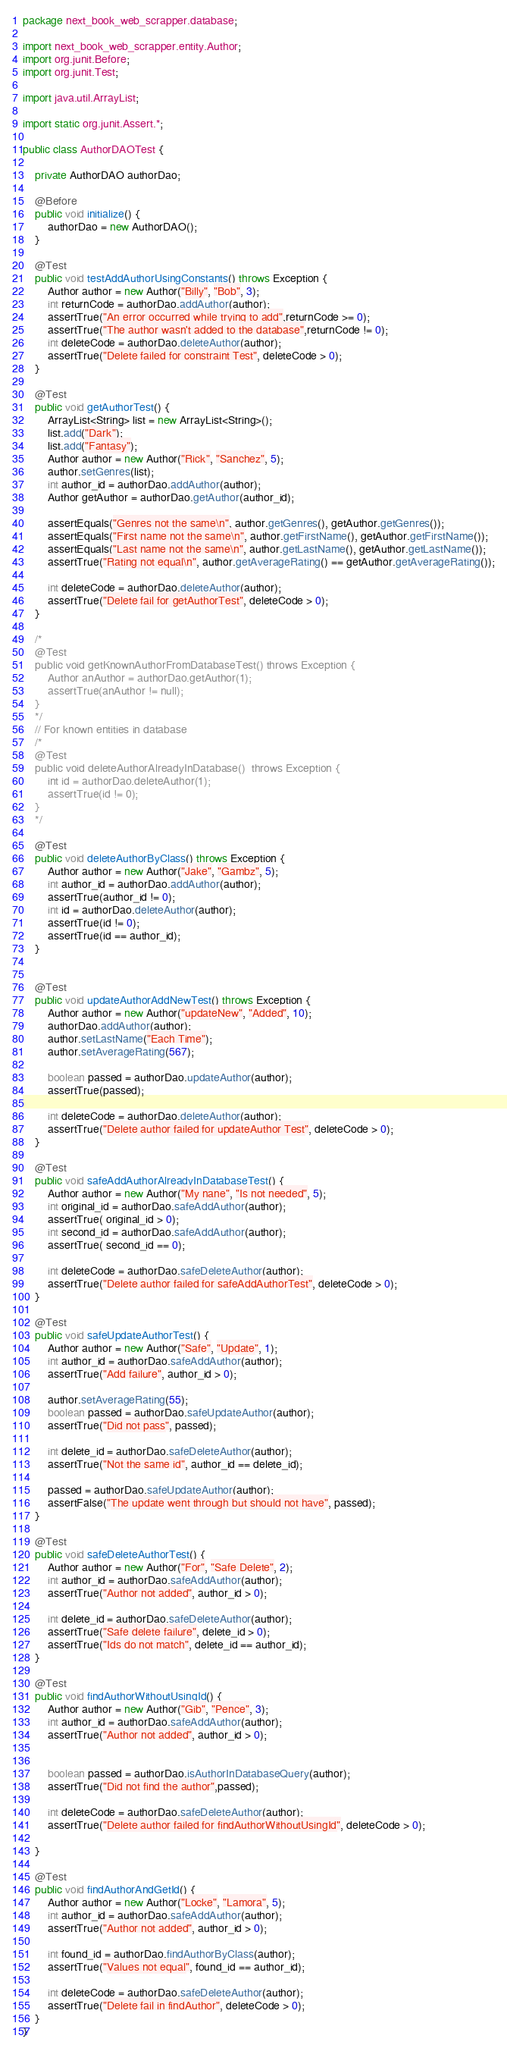<code> <loc_0><loc_0><loc_500><loc_500><_Java_>package next_book_web_scrapper.database;

import next_book_web_scrapper.entity.Author;
import org.junit.Before;
import org.junit.Test;

import java.util.ArrayList;

import static org.junit.Assert.*;

public class AuthorDAOTest {

    private AuthorDAO authorDao;

    @Before
    public void initialize() {
        authorDao = new AuthorDAO();
    }

    @Test
    public void testAddAuthorUsingConstants() throws Exception {
        Author author = new Author("Billy", "Bob", 3);
        int returnCode = authorDao.addAuthor(author);
        assertTrue("An error occurred while trying to add",returnCode >= 0);
        assertTrue("The author wasn't added to the database",returnCode != 0);
        int deleteCode = authorDao.deleteAuthor(author);
        assertTrue("Delete failed for constraint Test", deleteCode > 0);
    }

    @Test
    public void getAuthorTest() {
        ArrayList<String> list = new ArrayList<String>();
        list.add("Dark");
        list.add("Fantasy");
        Author author = new Author("Rick", "Sanchez", 5);
        author.setGenres(list);
        int author_id = authorDao.addAuthor(author);
        Author getAuthor = authorDao.getAuthor(author_id);

        assertEquals("Genres not the same\n", author.getGenres(), getAuthor.getGenres());
        assertEquals("First name not the same\n", author.getFirstName(), getAuthor.getFirstName());
        assertEquals("Last name not the same\n", author.getLastName(), getAuthor.getLastName());
        assertTrue("Rating not equal\n", author.getAverageRating() == getAuthor.getAverageRating());

        int deleteCode = authorDao.deleteAuthor(author);
        assertTrue("Delete fail for getAuthorTest", deleteCode > 0);
    }

    /*
    @Test
    public void getKnownAuthorFromDatabaseTest() throws Exception {
        Author anAuthor = authorDao.getAuthor(1);
        assertTrue(anAuthor != null);
    }
    */
    // For known entities in database
    /*
    @Test
    public void deleteAuthorAlreadyInDatabase()  throws Exception {
        int id = authorDao.deleteAuthor(1);
        assertTrue(id != 0);
    }
    */

    @Test
    public void deleteAuthorByClass() throws Exception {
        Author author = new Author("Jake", "Gambz", 5);
        int author_id = authorDao.addAuthor(author);
        assertTrue(author_id != 0);
        int id = authorDao.deleteAuthor(author);
        assertTrue(id != 0);
        assertTrue(id == author_id);
    }


    @Test
    public void updateAuthorAddNewTest() throws Exception {
        Author author = new Author("updateNew", "Added", 10);
        authorDao.addAuthor(author);
        author.setLastName("Each Time");
        author.setAverageRating(567);

        boolean passed = authorDao.updateAuthor(author);
        assertTrue(passed);

        int deleteCode = authorDao.deleteAuthor(author);
        assertTrue("Delete author failed for updateAuthor Test", deleteCode > 0);
    }

    @Test
    public void safeAddAuthorAlreadyInDatabaseTest() {
        Author author = new Author("My nane", "Is not needed", 5);
        int original_id = authorDao.safeAddAuthor(author);
        assertTrue( original_id > 0);
        int second_id = authorDao.safeAddAuthor(author);
        assertTrue( second_id == 0);

        int deleteCode = authorDao.safeDeleteAuthor(author);
        assertTrue("Delete author failed for safeAddAuthorTest", deleteCode > 0);
    }

    @Test
    public void safeUpdateAuthorTest() {
        Author author = new Author("Safe", "Update", 1);
        int author_id = authorDao.safeAddAuthor(author);
        assertTrue("Add failure", author_id > 0);

        author.setAverageRating(55);
        boolean passed = authorDao.safeUpdateAuthor(author);
        assertTrue("Did not pass", passed);

        int delete_id = authorDao.safeDeleteAuthor(author);
        assertTrue("Not the same id", author_id == delete_id);

        passed = authorDao.safeUpdateAuthor(author);
        assertFalse("The update went through but should not have", passed);
    }

    @Test
    public void safeDeleteAuthorTest() {
        Author author = new Author("For", "Safe Delete", 2);
        int author_id = authorDao.safeAddAuthor(author);
        assertTrue("Author not added", author_id > 0);

        int delete_id = authorDao.safeDeleteAuthor(author);
        assertTrue("Safe delete failure", delete_id > 0);
        assertTrue("Ids do not match", delete_id == author_id);
    }

    @Test
    public void findAuthorWithoutUsingId() {
        Author author = new Author("Gib", "Pence", 3);
        int author_id = authorDao.safeAddAuthor(author);
        assertTrue("Author not added", author_id > 0);


        boolean passed = authorDao.isAuthorInDatabaseQuery(author);
        assertTrue("Did not find the author",passed);

        int deleteCode = authorDao.safeDeleteAuthor(author);
        assertTrue("Delete author failed for findAuthorWithoutUsingId", deleteCode > 0);

    }

    @Test
    public void findAuthorAndGetId() {
        Author author = new Author("Locke", "Lamora", 5);
        int author_id = authorDao.safeAddAuthor(author);
        assertTrue("Author not added", author_id > 0);

        int found_id = authorDao.findAuthorByClass(author);
        assertTrue("Values not equal", found_id == author_id);

        int deleteCode = authorDao.safeDeleteAuthor(author);
        assertTrue("Delete fail in findAuthor", deleteCode > 0);
    }
}</code> 